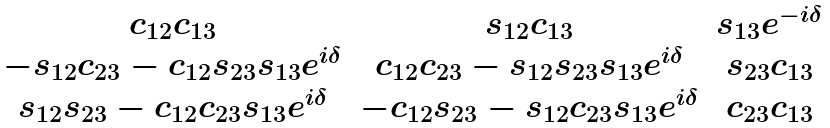<formula> <loc_0><loc_0><loc_500><loc_500>\begin{matrix} c _ { 1 2 } c _ { 1 3 } & s _ { 1 2 } c _ { 1 3 } & s _ { 1 3 } e ^ { - i \delta } \\ - s _ { 1 2 } c _ { 2 3 } - c _ { 1 2 } s _ { 2 3 } s _ { 1 3 } e ^ { i \delta } & c _ { 1 2 } c _ { 2 3 } - s _ { 1 2 } s _ { 2 3 } s _ { 1 3 } e ^ { i \delta } & s _ { 2 3 } c _ { 1 3 } \\ s _ { 1 2 } s _ { 2 3 } - c _ { 1 2 } c _ { 2 3 } s _ { 1 3 } e ^ { i \delta } & - c _ { 1 2 } s _ { 2 3 } - s _ { 1 2 } c _ { 2 3 } s _ { 1 3 } e ^ { i \delta } & c _ { 2 3 } c _ { 1 3 } \end{matrix}</formula> 